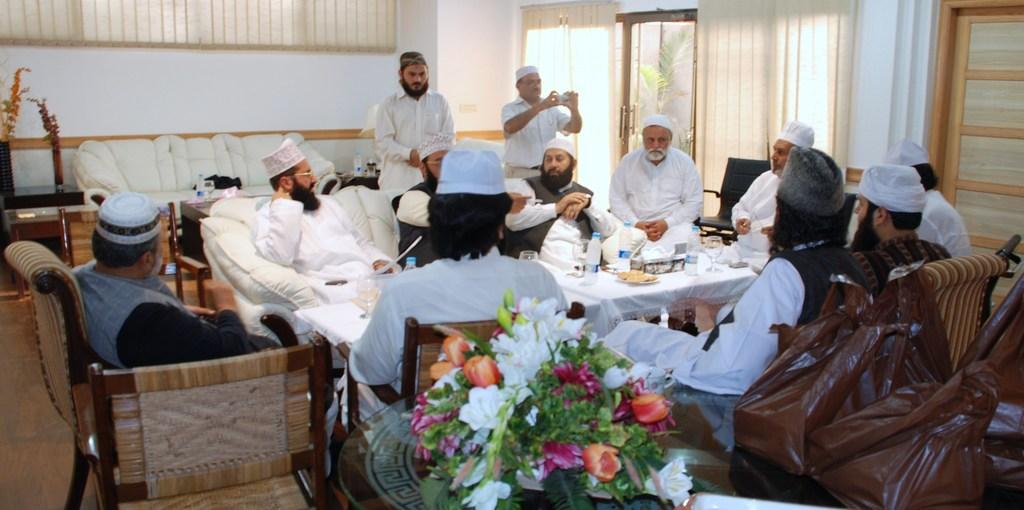In one or two sentences, can you explain what this image depicts? In this picture I can see there are a group of men sitting and they are having a table in front of them and there is some food, water bottles, there is a flower pot and a flower vase placed on the tables and there are carry bags. In the backdrop there is a man standing and clicking images. There is a door into right and there are few windows and curtains. 